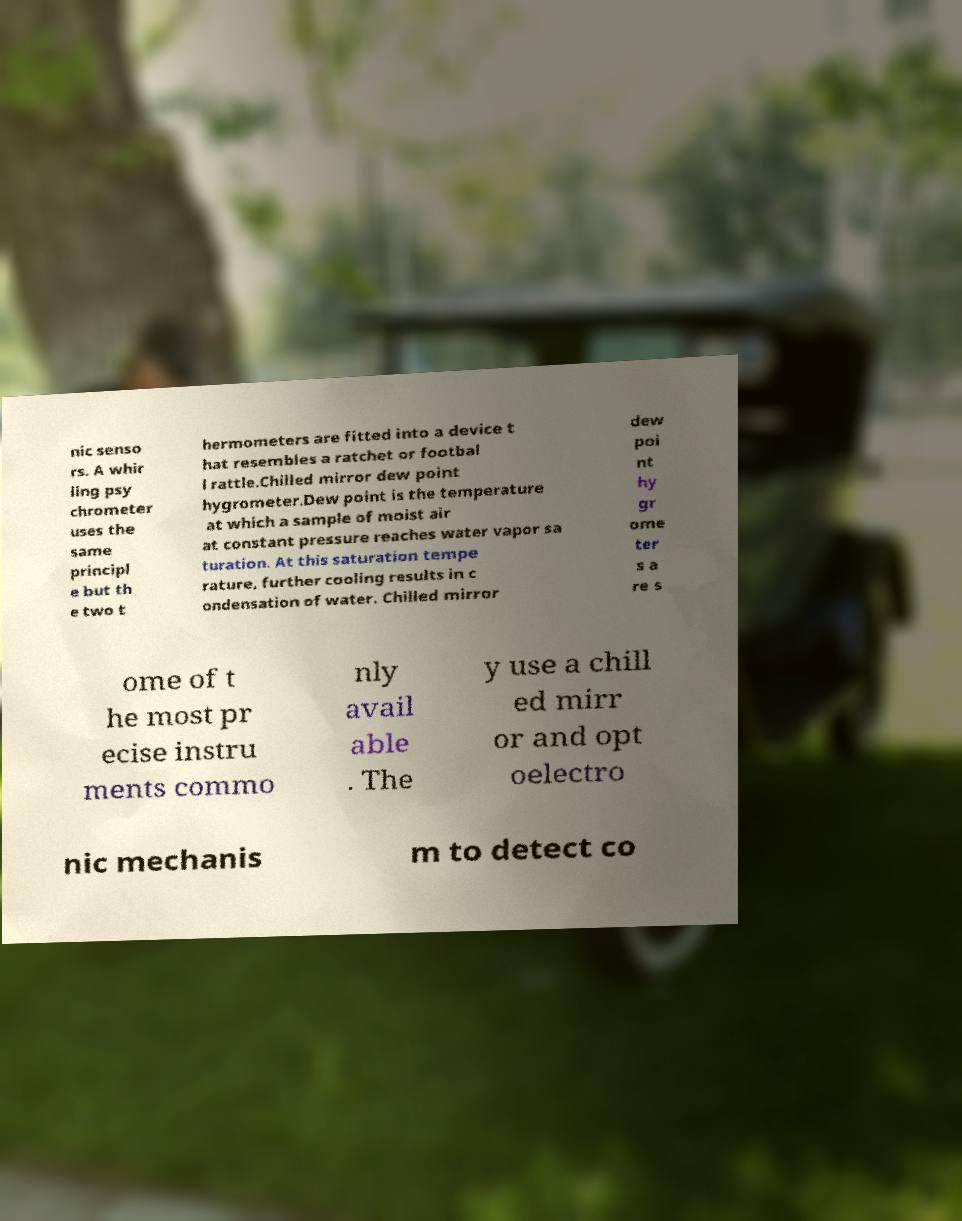Please read and relay the text visible in this image. What does it say? nic senso rs. A whir ling psy chrometer uses the same principl e but th e two t hermometers are fitted into a device t hat resembles a ratchet or footbal l rattle.Chilled mirror dew point hygrometer.Dew point is the temperature at which a sample of moist air at constant pressure reaches water vapor sa turation. At this saturation tempe rature, further cooling results in c ondensation of water. Chilled mirror dew poi nt hy gr ome ter s a re s ome of t he most pr ecise instru ments commo nly avail able . The y use a chill ed mirr or and opt oelectro nic mechanis m to detect co 